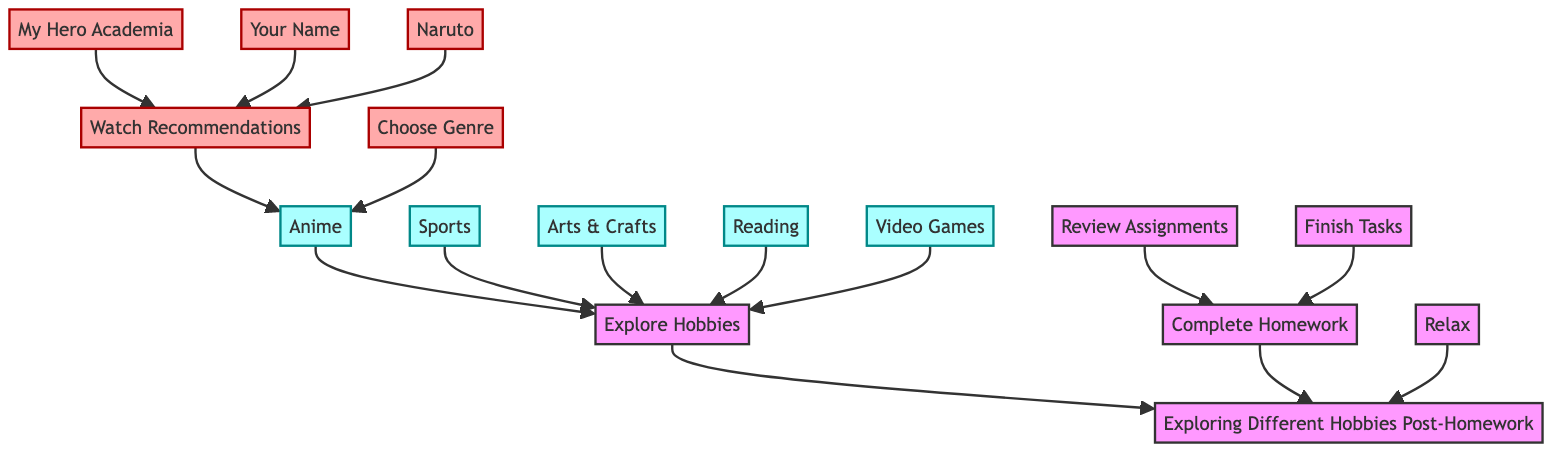What is the first step after completing homework? The diagram shows that after completing homework, the next step is to explore hobbies. This is indicated by the flow from "Complete Homework" to "Explore Hobbies."
Answer: Explore Hobbies How many hobby categories are listed in the diagram? The diagram shows five distinct hobbies listed: Anime, Sports, Arts & Crafts, Reading, and Video Games. Thus, by counting each unique category, we determine the number.
Answer: Five What are the options listed under Anime for choosing genres? The diagram indicates that under Anime, the options for choosing genres are Action, Romance, and Fantasy. These are directly connected under the "Choose Genre" node.
Answer: Action, Romance, Fantasy Which activity leads to watching anime recommendations? The diagram indicates that "Watch Recommendations" is a subsequent step after selecting "Anime." Since it follows from there, the activity directly leading to watching recommendations is "Choose Genre."
Answer: Choose Genre What follows after choosing "Video Games"? From the diagram, once "Video Games" is selected, the next step is to "Choose Console." This is the direct next node following the selection of the hobby.
Answer: Choose Console How many anime recommendations are provided? Examining the diagram, we see three specific anime recommendations: My Hero Academia, Your Name, and Naruto. Each recommendation is connected under the "Watch Recommendations" node.
Answer: Three What types of relaxation methods are included? The diagram presents two relaxation methods: Listening to Music and Meditation. These nodes are immediate connections leading from "Relax."
Answer: Listening to Music, Meditation Which hobby category includes painting? The diagram indicates that Arts & Crafts includes painting as one of its activities. It is directly listed under the Arts & Crafts node.
Answer: Arts & Crafts What is the final outcome or goal of the flowchart? The ultimate goal of the flowchart is to explore different hobbies post-homework, culminating in the final node at the top, which is "Exploring Different Hobbies Post-Homework."
Answer: Exploring Different Hobbies Post-Homework 